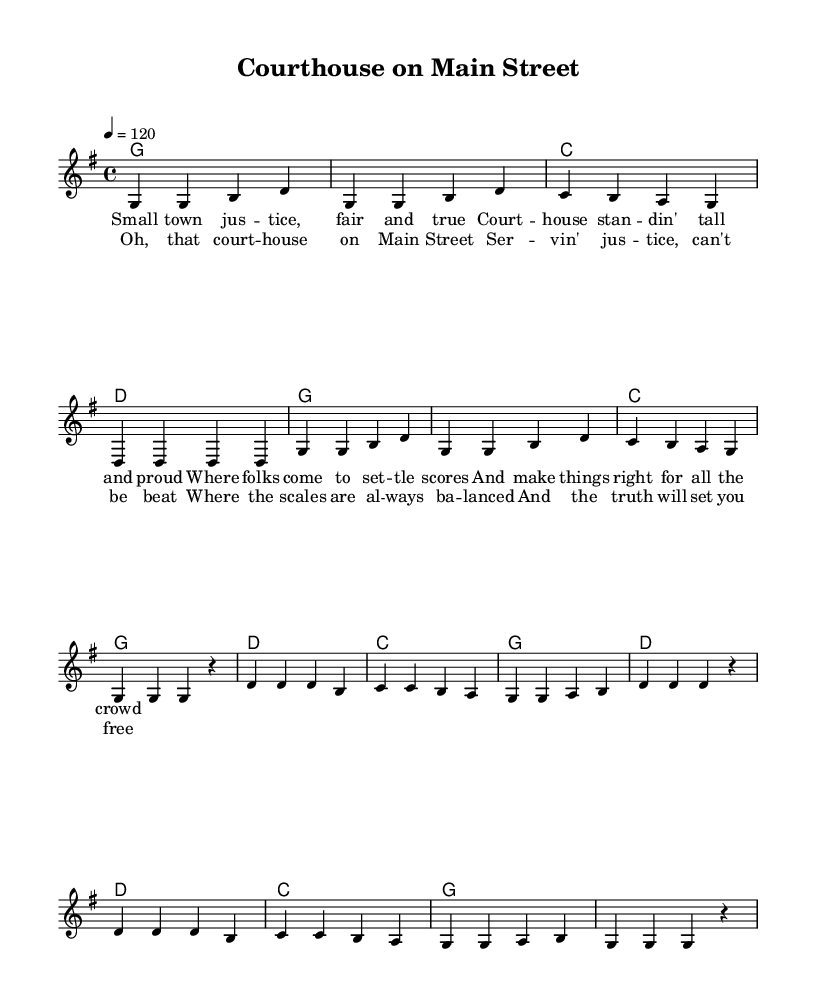What is the key signature of this music? The key signature indicated in the global section shows one sharp, which identifies the key as G major.
Answer: G major What is the time signature of the piece? The time signature is clearly stated in the global section, showing 4 beats per measure, which is represented as 4/4.
Answer: 4/4 What is the tempo marking of the music? The tempo marking shows a quarter note equals 120 beats per minute, indicating the speed at which the music should be played.
Answer: 120 How many measures are there in the verse? Counting the measures in the melody section indicates that there are 8 measures for the verse, as drawn from the four lines of the verse lyrics.
Answer: 8 What chord does the piece start with? The first chord listed in the harmonies section corresponds to the first measure of the melody and shows that it starts with a G major chord.
Answer: G What is the last lyric of the chorus? Analyzing the lyrics section, the last line of the chorus is "And the truth will set you free," making it possible to identify the content of the chorus’s conclusion.
Answer: And the truth will set you free What theme is celebrated in this song? By reviewing the lyrics and title of the music, it becomes apparent that the song celebrates small-town justice and the role of the courthouse.
Answer: Small-town justice 